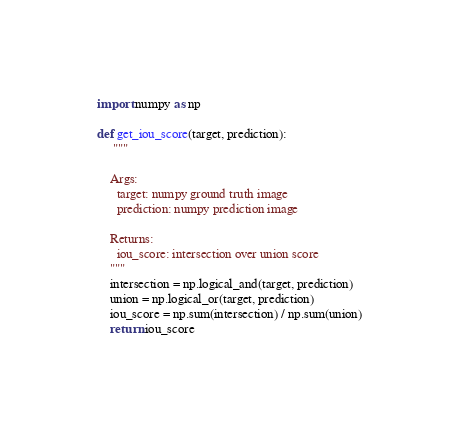Convert code to text. <code><loc_0><loc_0><loc_500><loc_500><_Python_>import numpy as np

def get_iou_score(target, prediction):
     """

    Args:
      target: numpy ground truth image
      prediction: numpy prediction image

    Returns:
      iou_score: intersection over union score
    """
    intersection = np.logical_and(target, prediction)
    union = np.logical_or(target, prediction)
    iou_score = np.sum(intersection) / np.sum(union)
    return iou_score</code> 